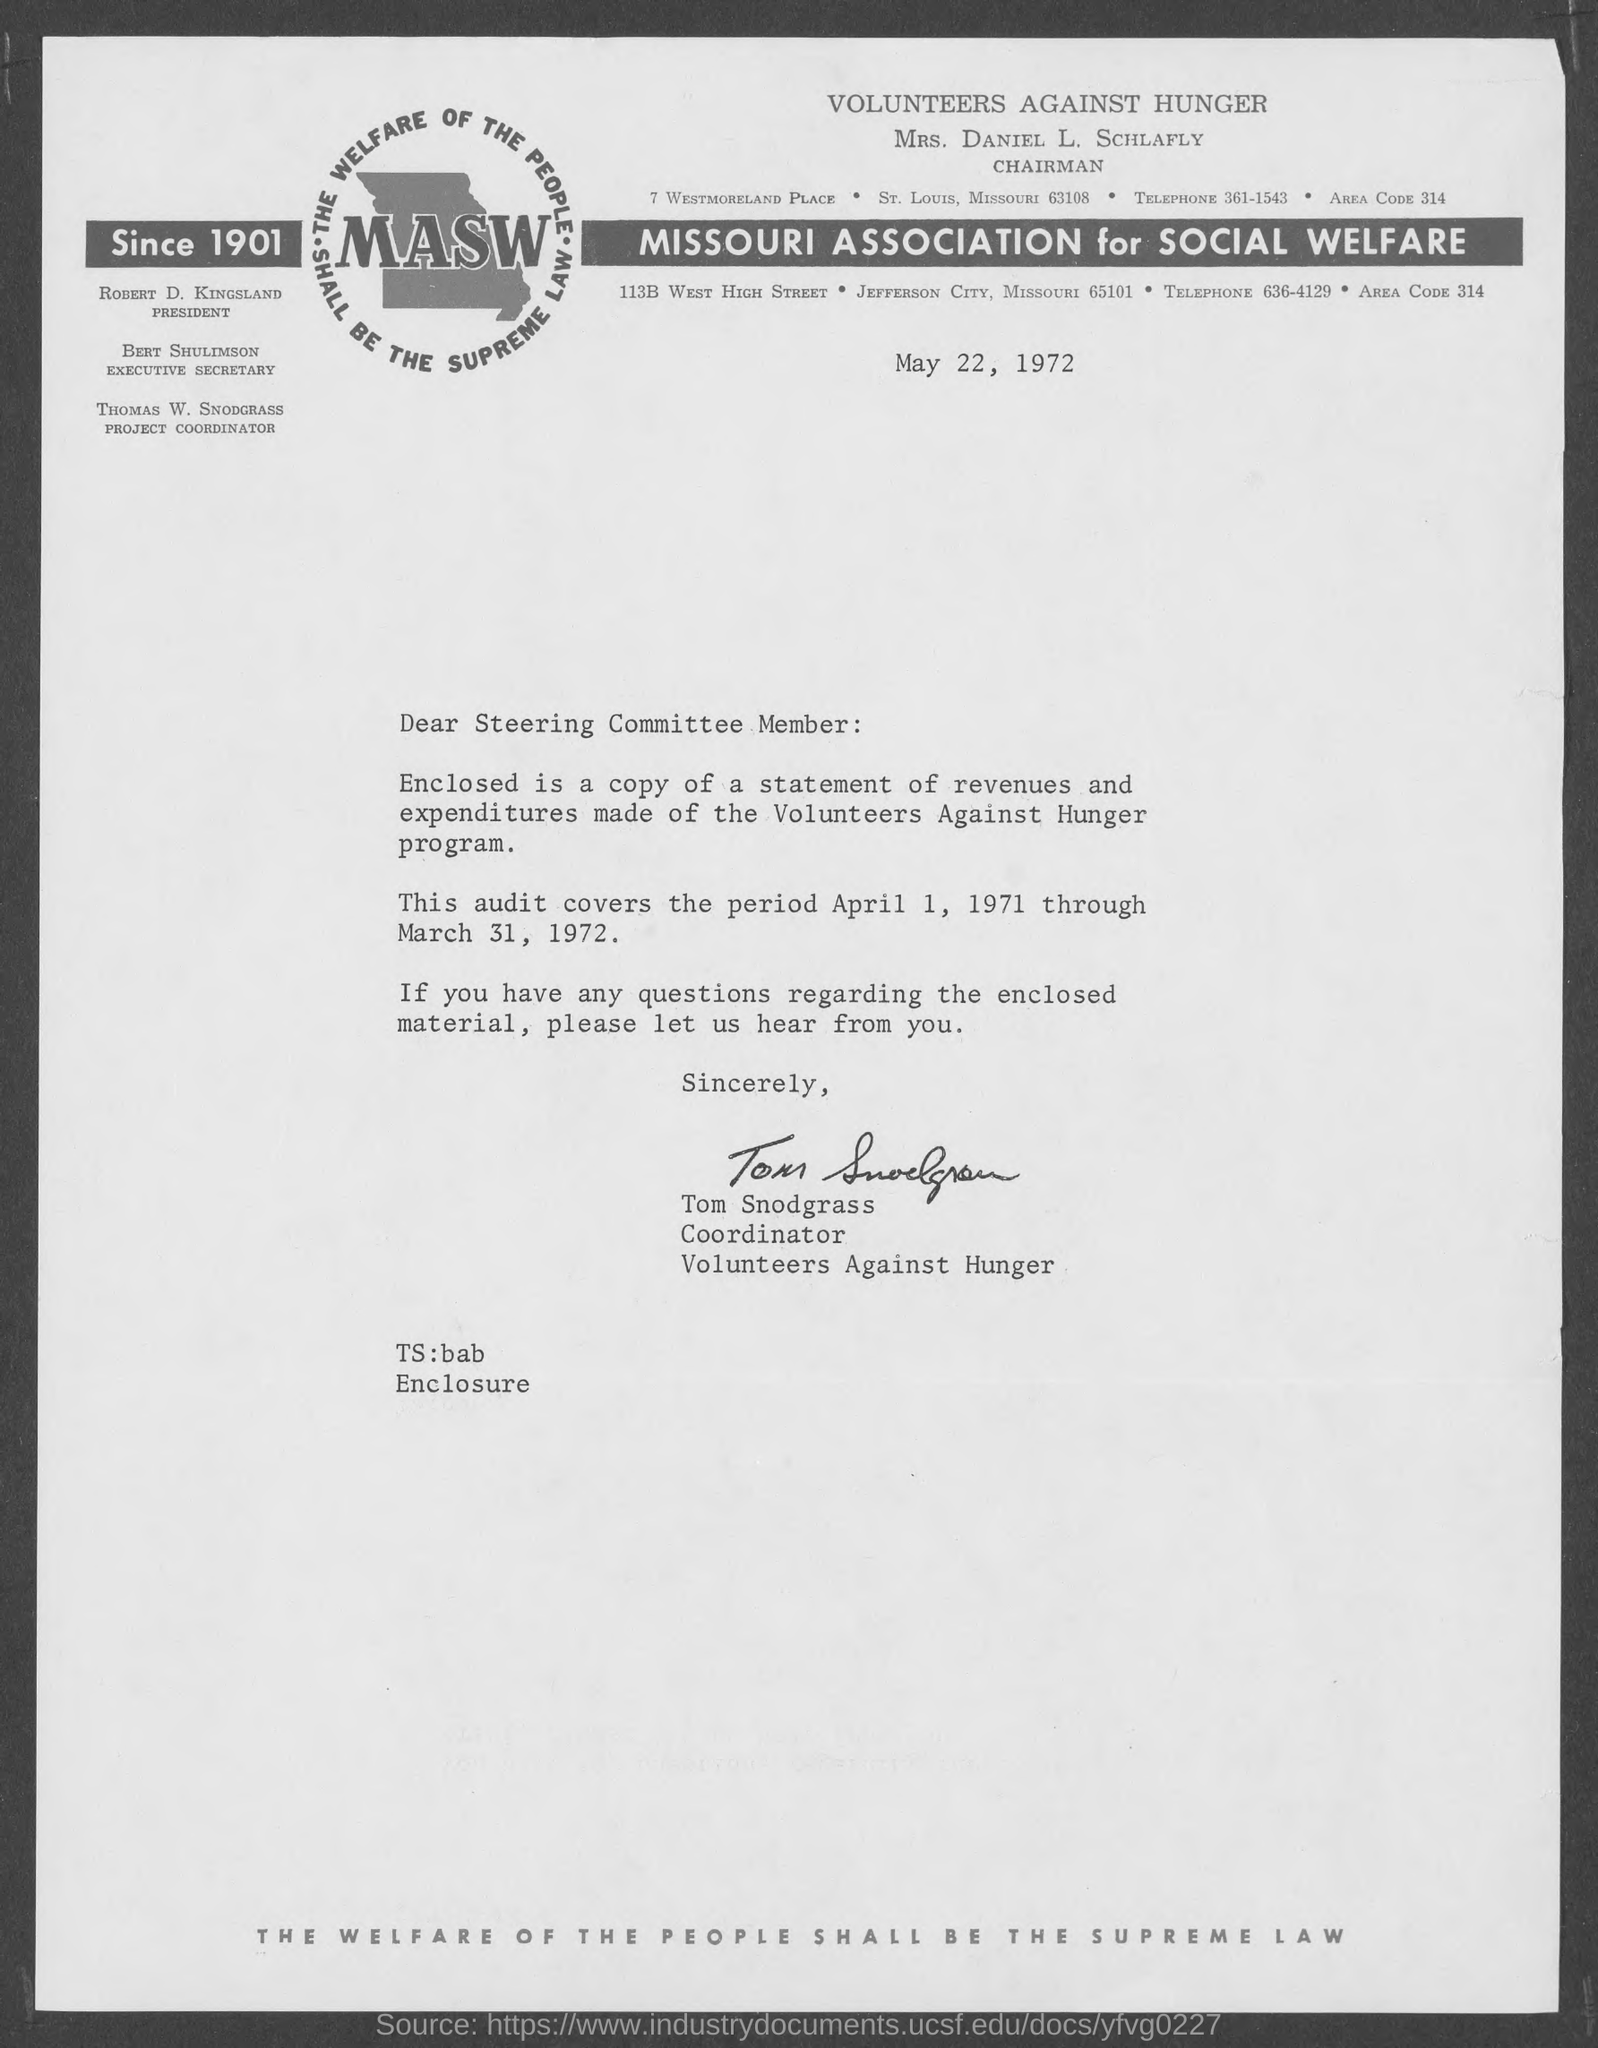Mention a couple of crucial points in this snapshot. The Chairman of Volunteers Against Hunger is Mrs. Daniel L. Schlafly. The document is dated May 22, 1972. It has been established that the MASW has been in existence since 1901. Bert Schulimson holds the title of Executive Secretary. ROBERT D. KINGSLAND is the President. 